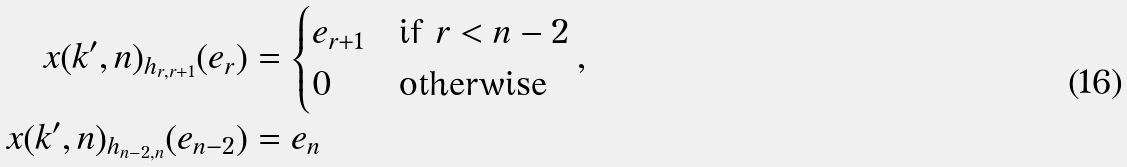Convert formula to latex. <formula><loc_0><loc_0><loc_500><loc_500>x ( k ^ { \prime } , n ) _ { h _ { r , r + 1 } } ( e _ { r } ) & = \begin{cases} e _ { r + 1 } & \text {if $r < n-2$} \\ 0 & \text {otherwise} \end{cases} , \\ x ( k ^ { \prime } , n ) _ { h _ { n - 2 , n } } ( e _ { n - 2 } ) & = e _ { n }</formula> 